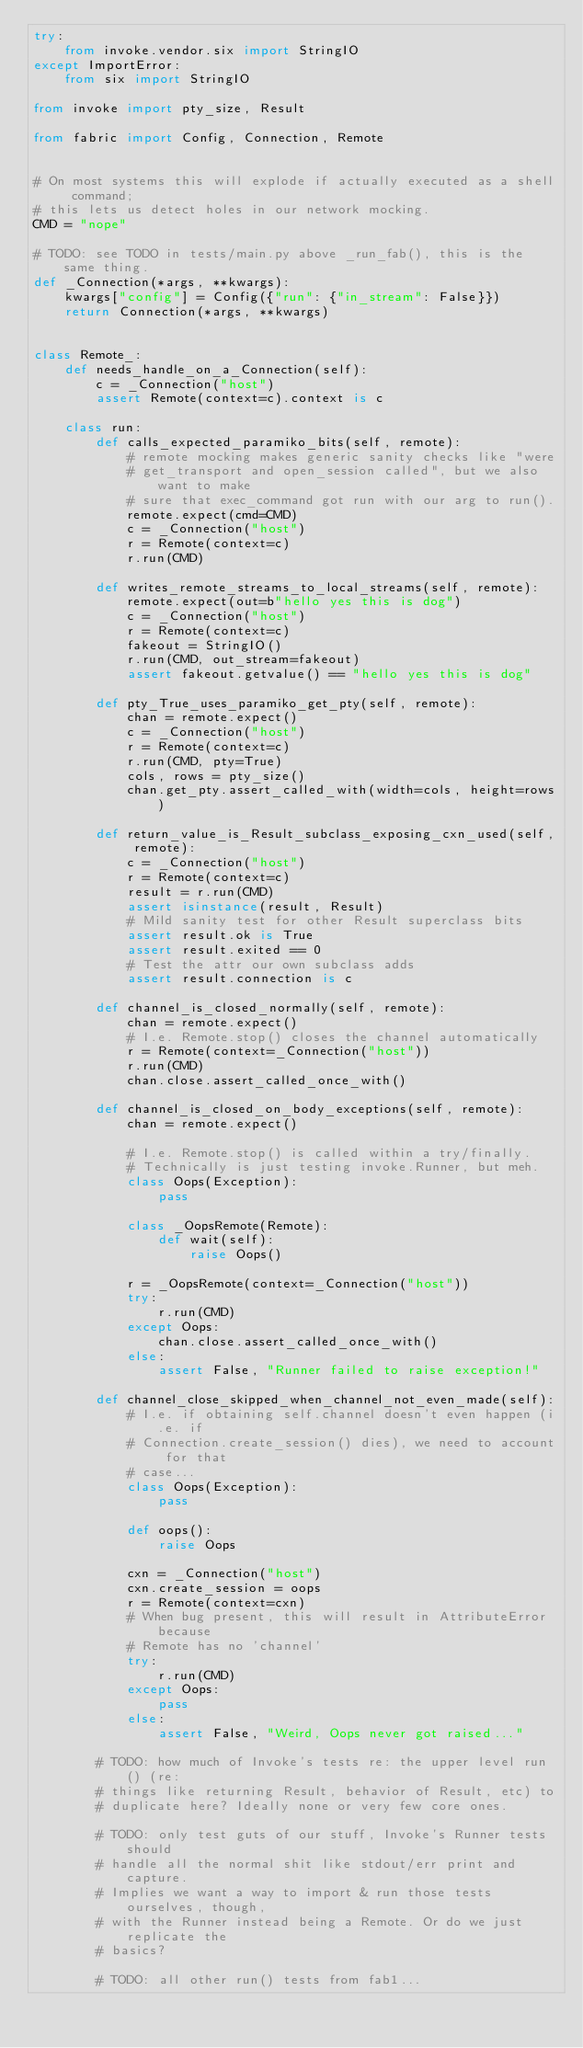Convert code to text. <code><loc_0><loc_0><loc_500><loc_500><_Python_>try:
    from invoke.vendor.six import StringIO
except ImportError:
    from six import StringIO

from invoke import pty_size, Result

from fabric import Config, Connection, Remote


# On most systems this will explode if actually executed as a shell command;
# this lets us detect holes in our network mocking.
CMD = "nope"

# TODO: see TODO in tests/main.py above _run_fab(), this is the same thing.
def _Connection(*args, **kwargs):
    kwargs["config"] = Config({"run": {"in_stream": False}})
    return Connection(*args, **kwargs)


class Remote_:
    def needs_handle_on_a_Connection(self):
        c = _Connection("host")
        assert Remote(context=c).context is c

    class run:
        def calls_expected_paramiko_bits(self, remote):
            # remote mocking makes generic sanity checks like "were
            # get_transport and open_session called", but we also want to make
            # sure that exec_command got run with our arg to run().
            remote.expect(cmd=CMD)
            c = _Connection("host")
            r = Remote(context=c)
            r.run(CMD)

        def writes_remote_streams_to_local_streams(self, remote):
            remote.expect(out=b"hello yes this is dog")
            c = _Connection("host")
            r = Remote(context=c)
            fakeout = StringIO()
            r.run(CMD, out_stream=fakeout)
            assert fakeout.getvalue() == "hello yes this is dog"

        def pty_True_uses_paramiko_get_pty(self, remote):
            chan = remote.expect()
            c = _Connection("host")
            r = Remote(context=c)
            r.run(CMD, pty=True)
            cols, rows = pty_size()
            chan.get_pty.assert_called_with(width=cols, height=rows)

        def return_value_is_Result_subclass_exposing_cxn_used(self, remote):
            c = _Connection("host")
            r = Remote(context=c)
            result = r.run(CMD)
            assert isinstance(result, Result)
            # Mild sanity test for other Result superclass bits
            assert result.ok is True
            assert result.exited == 0
            # Test the attr our own subclass adds
            assert result.connection is c

        def channel_is_closed_normally(self, remote):
            chan = remote.expect()
            # I.e. Remote.stop() closes the channel automatically
            r = Remote(context=_Connection("host"))
            r.run(CMD)
            chan.close.assert_called_once_with()

        def channel_is_closed_on_body_exceptions(self, remote):
            chan = remote.expect()

            # I.e. Remote.stop() is called within a try/finally.
            # Technically is just testing invoke.Runner, but meh.
            class Oops(Exception):
                pass

            class _OopsRemote(Remote):
                def wait(self):
                    raise Oops()

            r = _OopsRemote(context=_Connection("host"))
            try:
                r.run(CMD)
            except Oops:
                chan.close.assert_called_once_with()
            else:
                assert False, "Runner failed to raise exception!"

        def channel_close_skipped_when_channel_not_even_made(self):
            # I.e. if obtaining self.channel doesn't even happen (i.e. if
            # Connection.create_session() dies), we need to account for that
            # case...
            class Oops(Exception):
                pass

            def oops():
                raise Oops

            cxn = _Connection("host")
            cxn.create_session = oops
            r = Remote(context=cxn)
            # When bug present, this will result in AttributeError because
            # Remote has no 'channel'
            try:
                r.run(CMD)
            except Oops:
                pass
            else:
                assert False, "Weird, Oops never got raised..."

        # TODO: how much of Invoke's tests re: the upper level run() (re:
        # things like returning Result, behavior of Result, etc) to
        # duplicate here? Ideally none or very few core ones.

        # TODO: only test guts of our stuff, Invoke's Runner tests should
        # handle all the normal shit like stdout/err print and capture.
        # Implies we want a way to import & run those tests ourselves, though,
        # with the Runner instead being a Remote. Or do we just replicate the
        # basics?

        # TODO: all other run() tests from fab1...
</code> 